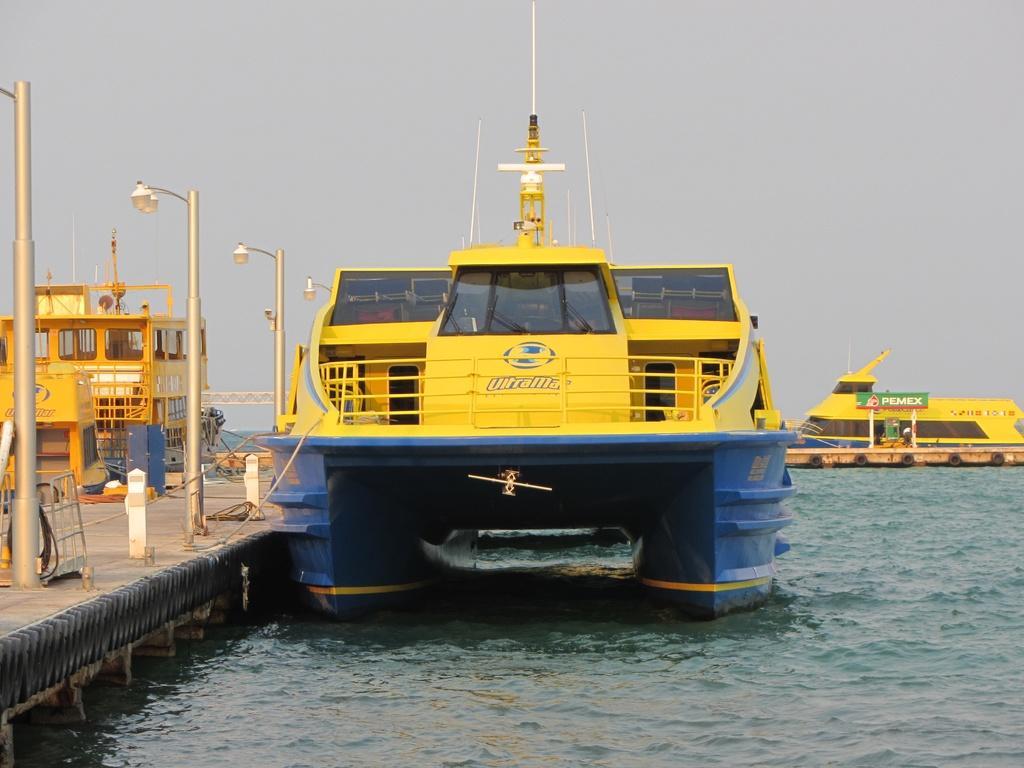How would you summarize this image in a sentence or two? In this image, I can see the boats on the water. On the left side of the image, there are street lights and few objects on the pathway. In the background, there is the sky. 